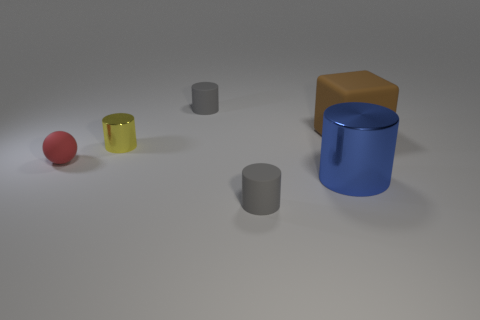There is a rubber cylinder that is in front of the red matte ball; is its color the same as the cylinder behind the brown rubber object?
Keep it short and to the point. Yes. Is there a yellow rubber thing that has the same shape as the blue metallic object?
Provide a succinct answer. No. Are there fewer big metal things that are in front of the blue shiny object than large matte blocks in front of the tiny red object?
Your response must be concise. No. The cube has what color?
Your answer should be compact. Brown. Is there a tiny yellow cylinder on the left side of the ball in front of the tiny yellow metal thing?
Give a very brief answer. No. What number of brown matte things are the same size as the brown rubber cube?
Your response must be concise. 0. There is a shiny cylinder that is behind the blue metal thing that is in front of the tiny ball; how many tiny yellow cylinders are to the left of it?
Offer a terse response. 0. How many matte objects are both behind the small metal cylinder and in front of the big shiny object?
Keep it short and to the point. 0. Is there any other thing that has the same color as the block?
Provide a succinct answer. No. What number of matte things are either big cylinders or small gray things?
Provide a short and direct response. 2. 